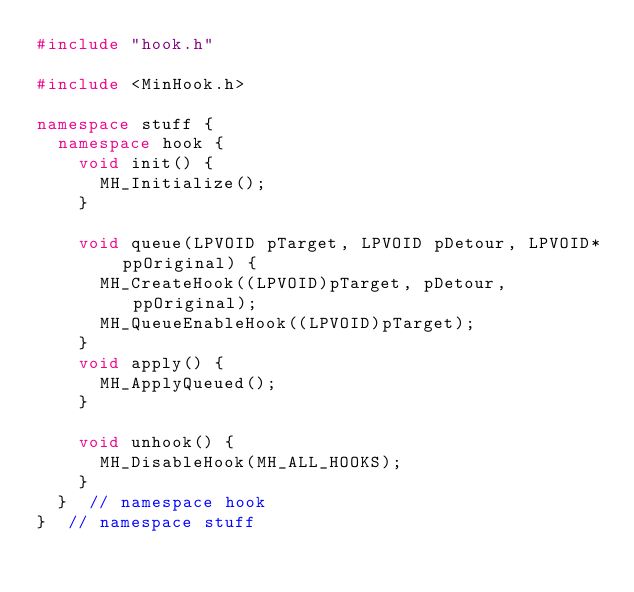Convert code to text. <code><loc_0><loc_0><loc_500><loc_500><_C++_>#include "hook.h"

#include <MinHook.h>

namespace stuff {
  namespace hook {
    void init() {
      MH_Initialize();
    }

    void queue(LPVOID pTarget, LPVOID pDetour, LPVOID* ppOriginal) {
      MH_CreateHook((LPVOID)pTarget, pDetour, ppOriginal);
      MH_QueueEnableHook((LPVOID)pTarget);
    }
    void apply() {
      MH_ApplyQueued();
    }

    void unhook() {
      MH_DisableHook(MH_ALL_HOOKS);
    }
  }  // namespace hook
}  // namespace stuff
</code> 